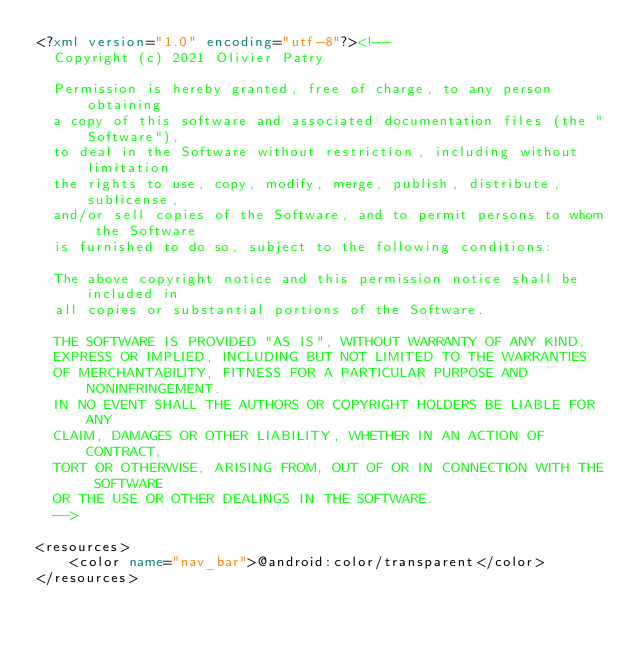Convert code to text. <code><loc_0><loc_0><loc_500><loc_500><_XML_><?xml version="1.0" encoding="utf-8"?><!--
  Copyright (c) 2021 Olivier Patry

  Permission is hereby granted, free of charge, to any person obtaining
  a copy of this software and associated documentation files (the "Software"),
  to deal in the Software without restriction, including without limitation
  the rights to use, copy, modify, merge, publish, distribute, sublicense,
  and/or sell copies of the Software, and to permit persons to whom the Software
  is furnished to do so, subject to the following conditions:

  The above copyright notice and this permission notice shall be included in
  all copies or substantial portions of the Software.

  THE SOFTWARE IS PROVIDED "AS IS", WITHOUT WARRANTY OF ANY KIND,
  EXPRESS OR IMPLIED, INCLUDING BUT NOT LIMITED TO THE WARRANTIES
  OF MERCHANTABILITY, FITNESS FOR A PARTICULAR PURPOSE AND NONINFRINGEMENT.
  IN NO EVENT SHALL THE AUTHORS OR COPYRIGHT HOLDERS BE LIABLE FOR ANY
  CLAIM, DAMAGES OR OTHER LIABILITY, WHETHER IN AN ACTION OF CONTRACT,
  TORT OR OTHERWISE, ARISING FROM, OUT OF OR IN CONNECTION WITH THE SOFTWARE
  OR THE USE OR OTHER DEALINGS IN THE SOFTWARE.
  -->

<resources>
    <color name="nav_bar">@android:color/transparent</color>
</resources></code> 